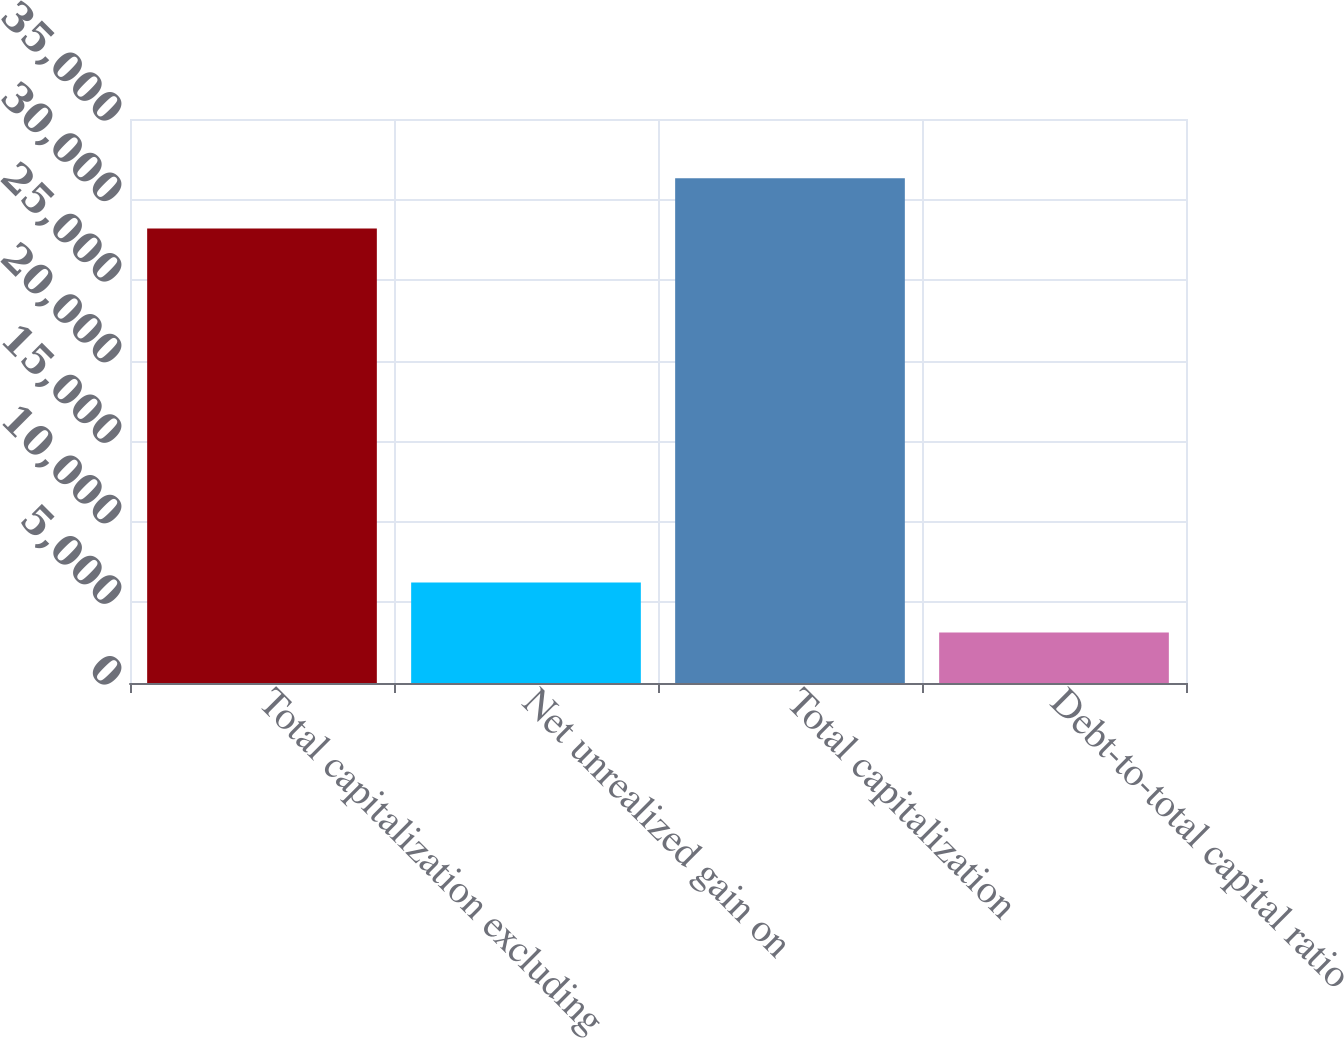Convert chart. <chart><loc_0><loc_0><loc_500><loc_500><bar_chart><fcel>Total capitalization excluding<fcel>Net unrealized gain on<fcel>Total capitalization<fcel>Debt-to-total capital ratio<nl><fcel>28211<fcel>6233.44<fcel>31317.1<fcel>3127.37<nl></chart> 